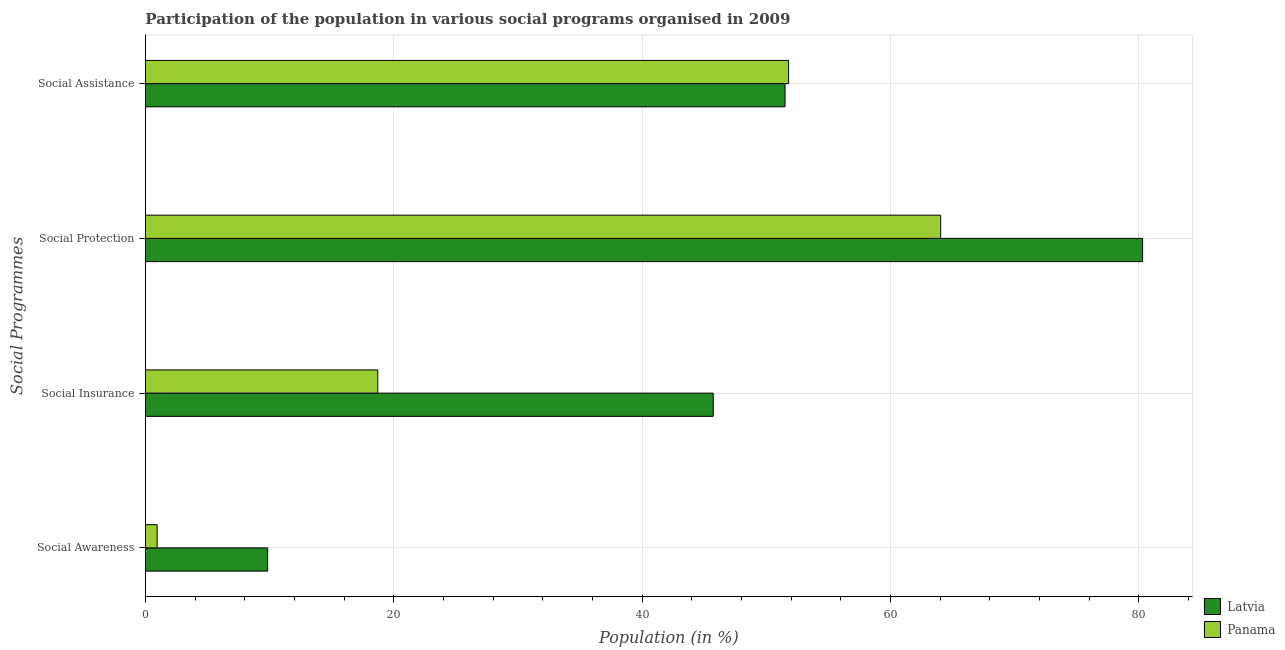How many groups of bars are there?
Give a very brief answer. 4. Are the number of bars on each tick of the Y-axis equal?
Your response must be concise. Yes. How many bars are there on the 4th tick from the bottom?
Your response must be concise. 2. What is the label of the 3rd group of bars from the top?
Give a very brief answer. Social Insurance. What is the participation of population in social protection programs in Latvia?
Provide a short and direct response. 80.3. Across all countries, what is the maximum participation of population in social protection programs?
Provide a short and direct response. 80.3. Across all countries, what is the minimum participation of population in social assistance programs?
Offer a very short reply. 51.51. In which country was the participation of population in social protection programs maximum?
Give a very brief answer. Latvia. In which country was the participation of population in social assistance programs minimum?
Provide a succinct answer. Latvia. What is the total participation of population in social assistance programs in the graph?
Ensure brevity in your answer.  103.3. What is the difference between the participation of population in social assistance programs in Panama and that in Latvia?
Keep it short and to the point. 0.29. What is the difference between the participation of population in social protection programs in Panama and the participation of population in social insurance programs in Latvia?
Offer a terse response. 18.32. What is the average participation of population in social protection programs per country?
Give a very brief answer. 72.17. What is the difference between the participation of population in social protection programs and participation of population in social insurance programs in Latvia?
Give a very brief answer. 34.58. In how many countries, is the participation of population in social protection programs greater than 48 %?
Offer a terse response. 2. What is the ratio of the participation of population in social awareness programs in Latvia to that in Panama?
Provide a succinct answer. 10.44. What is the difference between the highest and the second highest participation of population in social insurance programs?
Your answer should be compact. 27.01. What is the difference between the highest and the lowest participation of population in social insurance programs?
Your response must be concise. 27.01. Is the sum of the participation of population in social assistance programs in Panama and Latvia greater than the maximum participation of population in social awareness programs across all countries?
Your response must be concise. Yes. What does the 1st bar from the top in Social Awareness represents?
Make the answer very short. Panama. What does the 1st bar from the bottom in Social Protection represents?
Your answer should be very brief. Latvia. Does the graph contain any zero values?
Provide a succinct answer. No. Does the graph contain grids?
Provide a succinct answer. Yes. How many legend labels are there?
Make the answer very short. 2. How are the legend labels stacked?
Provide a succinct answer. Vertical. What is the title of the graph?
Your answer should be very brief. Participation of the population in various social programs organised in 2009. Does "Iraq" appear as one of the legend labels in the graph?
Your answer should be very brief. No. What is the label or title of the Y-axis?
Give a very brief answer. Social Programmes. What is the Population (in %) in Latvia in Social Awareness?
Provide a succinct answer. 9.84. What is the Population (in %) of Panama in Social Awareness?
Offer a terse response. 0.94. What is the Population (in %) of Latvia in Social Insurance?
Give a very brief answer. 45.72. What is the Population (in %) in Panama in Social Insurance?
Your answer should be very brief. 18.71. What is the Population (in %) of Latvia in Social Protection?
Provide a succinct answer. 80.3. What is the Population (in %) of Panama in Social Protection?
Your answer should be compact. 64.04. What is the Population (in %) in Latvia in Social Assistance?
Make the answer very short. 51.51. What is the Population (in %) in Panama in Social Assistance?
Your response must be concise. 51.79. Across all Social Programmes, what is the maximum Population (in %) of Latvia?
Your response must be concise. 80.3. Across all Social Programmes, what is the maximum Population (in %) in Panama?
Your response must be concise. 64.04. Across all Social Programmes, what is the minimum Population (in %) of Latvia?
Make the answer very short. 9.84. Across all Social Programmes, what is the minimum Population (in %) of Panama?
Keep it short and to the point. 0.94. What is the total Population (in %) of Latvia in the graph?
Provide a short and direct response. 187.37. What is the total Population (in %) of Panama in the graph?
Your response must be concise. 135.49. What is the difference between the Population (in %) of Latvia in Social Awareness and that in Social Insurance?
Ensure brevity in your answer.  -35.88. What is the difference between the Population (in %) of Panama in Social Awareness and that in Social Insurance?
Offer a terse response. -17.77. What is the difference between the Population (in %) of Latvia in Social Awareness and that in Social Protection?
Your answer should be compact. -70.46. What is the difference between the Population (in %) of Panama in Social Awareness and that in Social Protection?
Offer a very short reply. -63.1. What is the difference between the Population (in %) in Latvia in Social Awareness and that in Social Assistance?
Keep it short and to the point. -41.67. What is the difference between the Population (in %) of Panama in Social Awareness and that in Social Assistance?
Your answer should be compact. -50.85. What is the difference between the Population (in %) of Latvia in Social Insurance and that in Social Protection?
Your response must be concise. -34.58. What is the difference between the Population (in %) in Panama in Social Insurance and that in Social Protection?
Make the answer very short. -45.33. What is the difference between the Population (in %) in Latvia in Social Insurance and that in Social Assistance?
Give a very brief answer. -5.78. What is the difference between the Population (in %) in Panama in Social Insurance and that in Social Assistance?
Offer a very short reply. -33.08. What is the difference between the Population (in %) of Latvia in Social Protection and that in Social Assistance?
Your response must be concise. 28.8. What is the difference between the Population (in %) in Panama in Social Protection and that in Social Assistance?
Make the answer very short. 12.25. What is the difference between the Population (in %) in Latvia in Social Awareness and the Population (in %) in Panama in Social Insurance?
Your response must be concise. -8.87. What is the difference between the Population (in %) in Latvia in Social Awareness and the Population (in %) in Panama in Social Protection?
Offer a terse response. -54.2. What is the difference between the Population (in %) in Latvia in Social Awareness and the Population (in %) in Panama in Social Assistance?
Make the answer very short. -41.95. What is the difference between the Population (in %) of Latvia in Social Insurance and the Population (in %) of Panama in Social Protection?
Keep it short and to the point. -18.32. What is the difference between the Population (in %) of Latvia in Social Insurance and the Population (in %) of Panama in Social Assistance?
Provide a succinct answer. -6.07. What is the difference between the Population (in %) of Latvia in Social Protection and the Population (in %) of Panama in Social Assistance?
Provide a short and direct response. 28.51. What is the average Population (in %) in Latvia per Social Programmes?
Your answer should be compact. 46.84. What is the average Population (in %) of Panama per Social Programmes?
Offer a very short reply. 33.87. What is the difference between the Population (in %) of Latvia and Population (in %) of Panama in Social Awareness?
Provide a short and direct response. 8.9. What is the difference between the Population (in %) of Latvia and Population (in %) of Panama in Social Insurance?
Offer a very short reply. 27.01. What is the difference between the Population (in %) of Latvia and Population (in %) of Panama in Social Protection?
Ensure brevity in your answer.  16.26. What is the difference between the Population (in %) of Latvia and Population (in %) of Panama in Social Assistance?
Your response must be concise. -0.29. What is the ratio of the Population (in %) in Latvia in Social Awareness to that in Social Insurance?
Give a very brief answer. 0.22. What is the ratio of the Population (in %) of Panama in Social Awareness to that in Social Insurance?
Your answer should be very brief. 0.05. What is the ratio of the Population (in %) in Latvia in Social Awareness to that in Social Protection?
Ensure brevity in your answer.  0.12. What is the ratio of the Population (in %) in Panama in Social Awareness to that in Social Protection?
Your answer should be very brief. 0.01. What is the ratio of the Population (in %) in Latvia in Social Awareness to that in Social Assistance?
Ensure brevity in your answer.  0.19. What is the ratio of the Population (in %) in Panama in Social Awareness to that in Social Assistance?
Offer a terse response. 0.02. What is the ratio of the Population (in %) of Latvia in Social Insurance to that in Social Protection?
Offer a very short reply. 0.57. What is the ratio of the Population (in %) of Panama in Social Insurance to that in Social Protection?
Make the answer very short. 0.29. What is the ratio of the Population (in %) of Latvia in Social Insurance to that in Social Assistance?
Your answer should be very brief. 0.89. What is the ratio of the Population (in %) of Panama in Social Insurance to that in Social Assistance?
Offer a very short reply. 0.36. What is the ratio of the Population (in %) in Latvia in Social Protection to that in Social Assistance?
Make the answer very short. 1.56. What is the ratio of the Population (in %) of Panama in Social Protection to that in Social Assistance?
Provide a short and direct response. 1.24. What is the difference between the highest and the second highest Population (in %) of Latvia?
Keep it short and to the point. 28.8. What is the difference between the highest and the second highest Population (in %) in Panama?
Provide a succinct answer. 12.25. What is the difference between the highest and the lowest Population (in %) of Latvia?
Your answer should be compact. 70.46. What is the difference between the highest and the lowest Population (in %) in Panama?
Your answer should be compact. 63.1. 